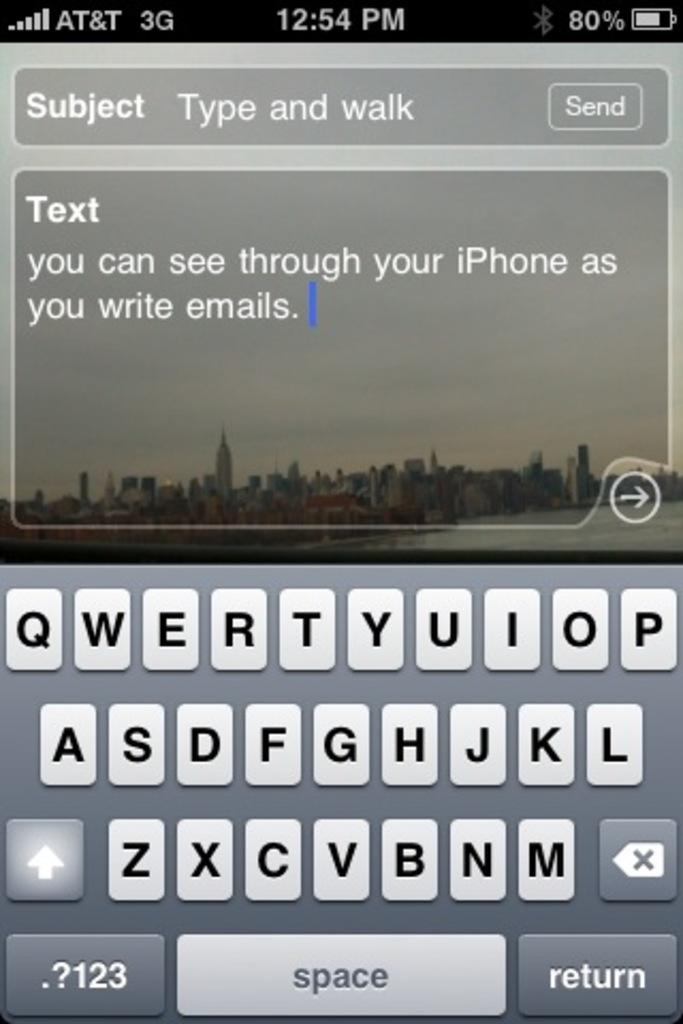<image>
Relay a brief, clear account of the picture shown. An AT&T services iPhone shows a typing screen and keyboard. 